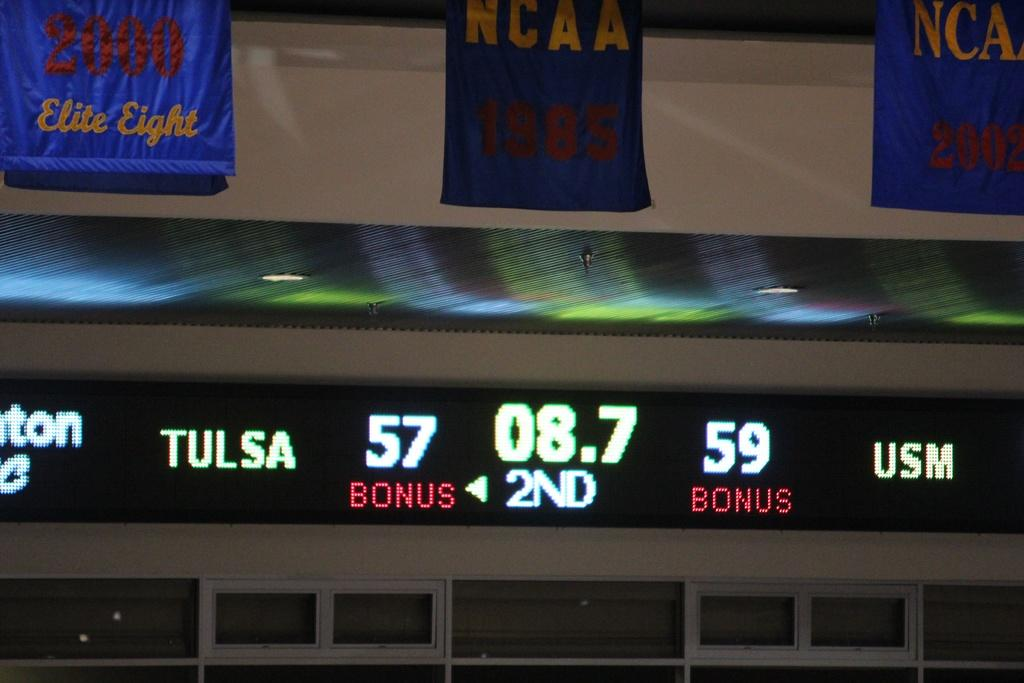<image>
Describe the image concisely. Sports scoreboard above windows that says Tulsa in white. 